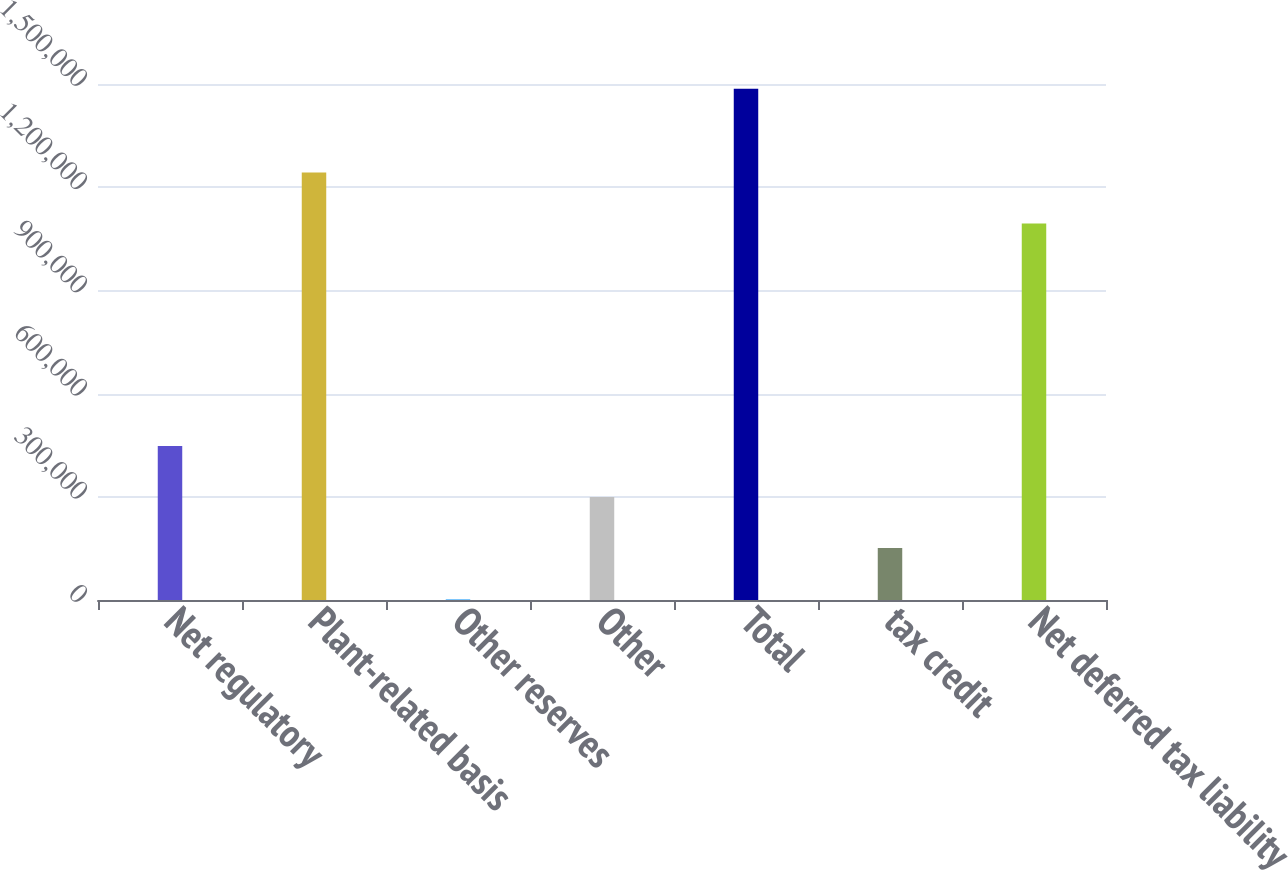<chart> <loc_0><loc_0><loc_500><loc_500><bar_chart><fcel>Net regulatory<fcel>Plant-related basis<fcel>Other reserves<fcel>Other<fcel>Total<fcel>tax credit<fcel>Net deferred tax liability<nl><fcel>447756<fcel>1.24267e+06<fcel>2686<fcel>299399<fcel>1.48625e+06<fcel>151043<fcel>1.09432e+06<nl></chart> 